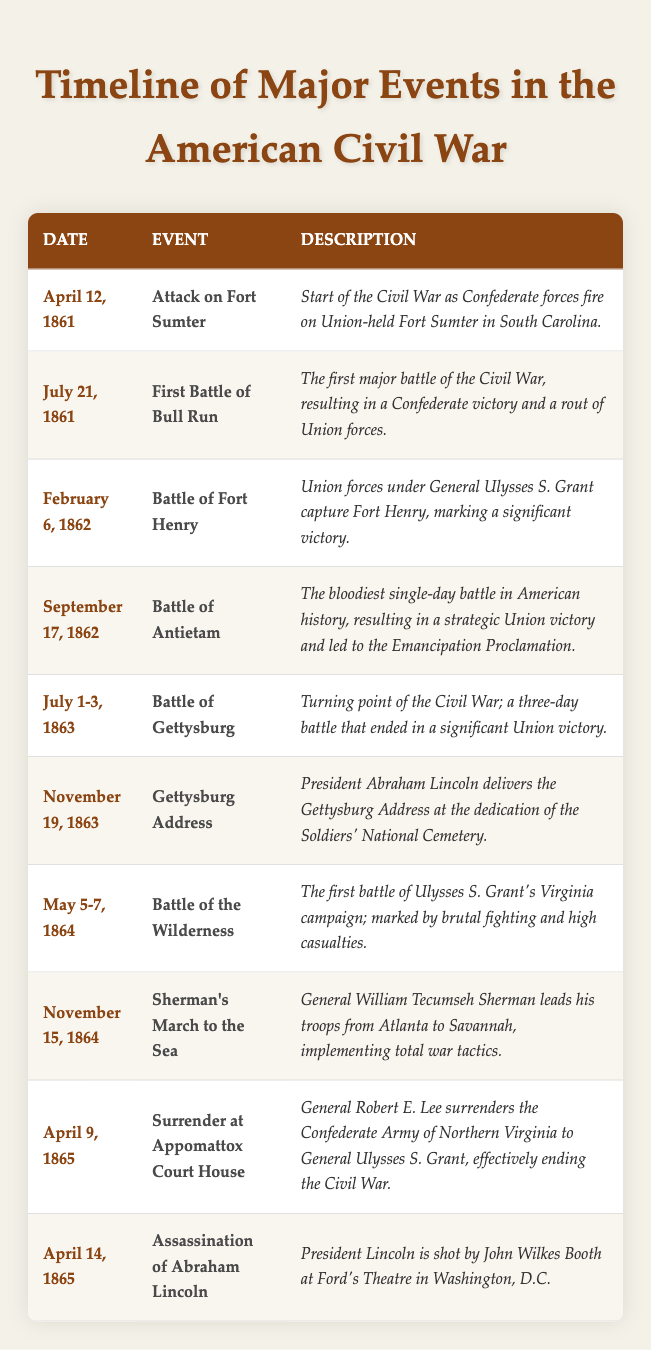What event marked the start of the Civil War? According to the table, the event that marked the start of the Civil War is the "Attack on Fort Sumter," which occurred on April 12, 1861.
Answer: Attack on Fort Sumter How many days did the Battle of Gettysburg last? The table states that the Battle of Gettysburg took place from July 1 to July 3, 1863, which totals 3 days.
Answer: 3 days Which event took place immediately after the Surrender at Appomattox Court House? The Surrender at Appomattox Court House occurred on April 9, 1865. The next event in chronological order listed in the table is the "Assassination of Abraham Lincoln" on April 14, 1865.
Answer: Assassination of Abraham Lincoln Was the Battle of Antietam the deadliest single-day battle in American history? Yes, the table describes the Battle of Antietam as "the bloodiest single-day battle in American history," confirming that this statement is true.
Answer: Yes What was the significance of the Gettysburg Address? The table indicates that the Gettysburg Address was delivered by President Abraham Lincoln on November 19, 1863, at the dedication of the Soldiers' National Cemetery, highlighting its historical significance in commemorating the fallen and redefining the purpose of the war.
Answer: Redefined the purpose of the war What is the time span from the start of the Civil War to the Surrender at Appomattox Court House? The Civil War began on April 12, 1861, and ended with the Surrender at Appomattox Court House on April 9, 1865. To calculate the time span, count the years and months: from April 1861 to April 1865 is approximately 4 years.
Answer: 4 years How many major events listed occurred in 1864? The table shows that there are two major events in 1864: the "Battle of the Wilderness" on May 5-7 and "Sherman's March to the Sea" on November 15. Therefore, the total is 2 events.
Answer: 2 events Which event took place before Sherman's March to the Sea? Sherman's March to the Sea occurred on November 15, 1864. The event that precedes it in the table is the "Battle of the Wilderness," which took place from May 5 to May 7, 1864.
Answer: Battle of the Wilderness What was a notable outcome of the Battle of Antietam? The table states that the Battle of Antietam resulted in a "strategic Union victory" and led to the Emancipation Proclamation, indicating its importance for the Union's war strategy and the abolition of slavery.
Answer: Led to the Emancipation Proclamation 